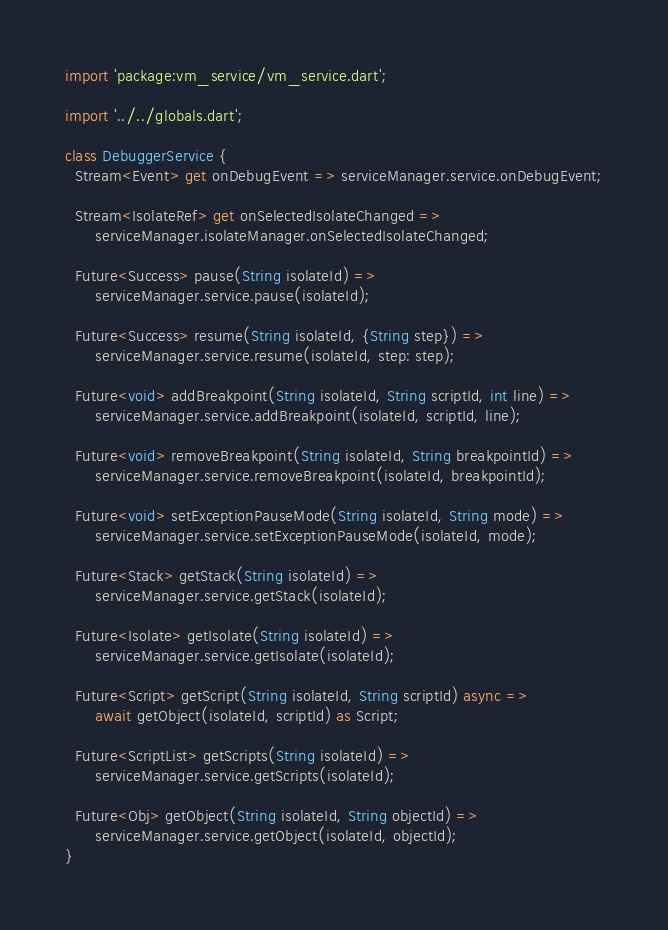<code> <loc_0><loc_0><loc_500><loc_500><_Dart_>import 'package:vm_service/vm_service.dart';

import '../../globals.dart';

class DebuggerService {
  Stream<Event> get onDebugEvent => serviceManager.service.onDebugEvent;

  Stream<IsolateRef> get onSelectedIsolateChanged =>
      serviceManager.isolateManager.onSelectedIsolateChanged;

  Future<Success> pause(String isolateId) =>
      serviceManager.service.pause(isolateId);

  Future<Success> resume(String isolateId, {String step}) =>
      serviceManager.service.resume(isolateId, step: step);

  Future<void> addBreakpoint(String isolateId, String scriptId, int line) =>
      serviceManager.service.addBreakpoint(isolateId, scriptId, line);

  Future<void> removeBreakpoint(String isolateId, String breakpointId) =>
      serviceManager.service.removeBreakpoint(isolateId, breakpointId);

  Future<void> setExceptionPauseMode(String isolateId, String mode) =>
      serviceManager.service.setExceptionPauseMode(isolateId, mode);

  Future<Stack> getStack(String isolateId) =>
      serviceManager.service.getStack(isolateId);

  Future<Isolate> getIsolate(String isolateId) =>
      serviceManager.service.getIsolate(isolateId);

  Future<Script> getScript(String isolateId, String scriptId) async =>
      await getObject(isolateId, scriptId) as Script;

  Future<ScriptList> getScripts(String isolateId) =>
      serviceManager.service.getScripts(isolateId);

  Future<Obj> getObject(String isolateId, String objectId) =>
      serviceManager.service.getObject(isolateId, objectId);
}
</code> 